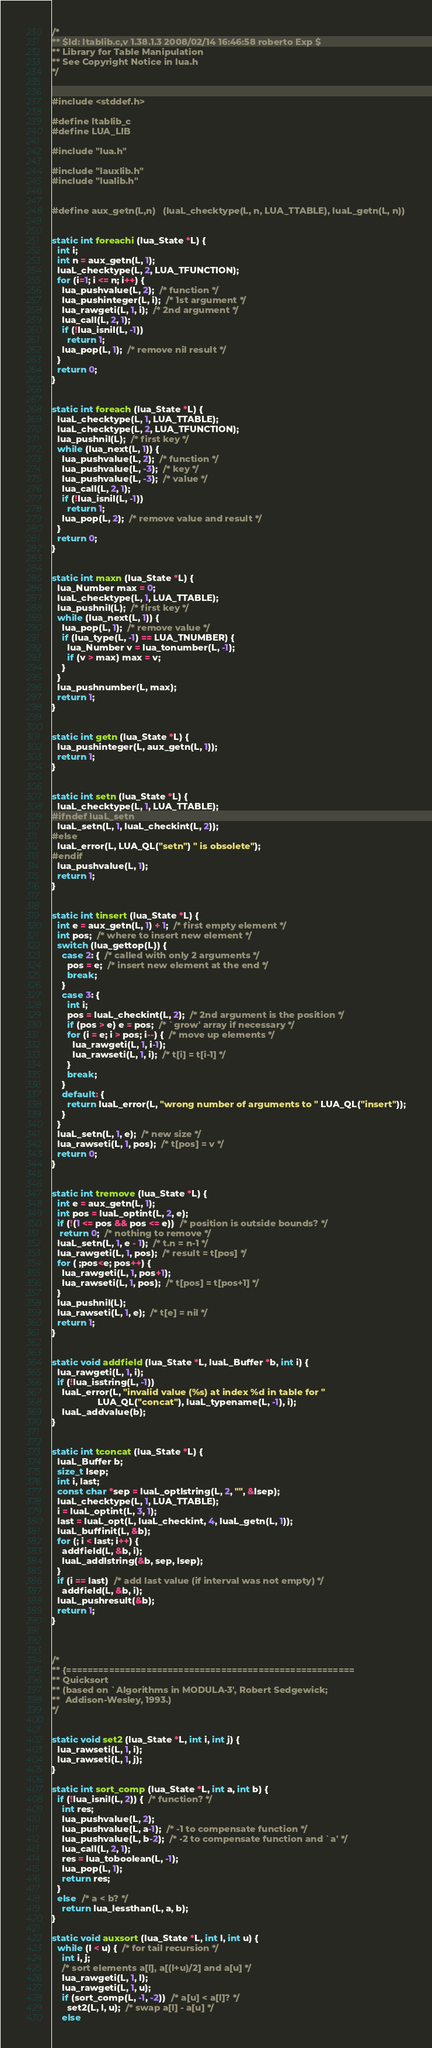<code> <loc_0><loc_0><loc_500><loc_500><_C_>/*
** $Id: ltablib.c,v 1.38.1.3 2008/02/14 16:46:58 roberto Exp $
** Library for Table Manipulation
** See Copyright Notice in lua.h
*/


#include <stddef.h>

#define ltablib_c
#define LUA_LIB

#include "lua.h"

#include "lauxlib.h"
#include "lualib.h"


#define aux_getn(L,n)   (luaL_checktype(L, n, LUA_TTABLE), luaL_getn(L, n))


static int foreachi (lua_State *L) {
  int i;
  int n = aux_getn(L, 1);
  luaL_checktype(L, 2, LUA_TFUNCTION);
  for (i=1; i <= n; i++) {
    lua_pushvalue(L, 2);  /* function */
    lua_pushinteger(L, i);  /* 1st argument */
    lua_rawgeti(L, 1, i);  /* 2nd argument */
    lua_call(L, 2, 1);
    if (!lua_isnil(L, -1))
      return 1;
    lua_pop(L, 1);  /* remove nil result */
  }
  return 0;
}


static int foreach (lua_State *L) {
  luaL_checktype(L, 1, LUA_TTABLE);
  luaL_checktype(L, 2, LUA_TFUNCTION);
  lua_pushnil(L);  /* first key */
  while (lua_next(L, 1)) {
    lua_pushvalue(L, 2);  /* function */
    lua_pushvalue(L, -3);  /* key */
    lua_pushvalue(L, -3);  /* value */
    lua_call(L, 2, 1);
    if (!lua_isnil(L, -1))
      return 1;
    lua_pop(L, 2);  /* remove value and result */
  }
  return 0;
}


static int maxn (lua_State *L) {
  lua_Number max = 0;
  luaL_checktype(L, 1, LUA_TTABLE);
  lua_pushnil(L);  /* first key */
  while (lua_next(L, 1)) {
    lua_pop(L, 1);  /* remove value */
    if (lua_type(L, -1) == LUA_TNUMBER) {
      lua_Number v = lua_tonumber(L, -1);
      if (v > max) max = v;
    }
  }
  lua_pushnumber(L, max);
  return 1;
}


static int getn (lua_State *L) {
  lua_pushinteger(L, aux_getn(L, 1));
  return 1;
}


static int setn (lua_State *L) {
  luaL_checktype(L, 1, LUA_TTABLE);
#ifndef luaL_setn
  luaL_setn(L, 1, luaL_checkint(L, 2));
#else
  luaL_error(L, LUA_QL("setn") " is obsolete");
#endif
  lua_pushvalue(L, 1);
  return 1;
}


static int tinsert (lua_State *L) {
  int e = aux_getn(L, 1) + 1;  /* first empty element */
  int pos;  /* where to insert new element */
  switch (lua_gettop(L)) {
    case 2: {  /* called with only 2 arguments */
      pos = e;  /* insert new element at the end */
      break;
    }
    case 3: {
      int i;
      pos = luaL_checkint(L, 2);  /* 2nd argument is the position */
      if (pos > e) e = pos;  /* `grow' array if necessary */
      for (i = e; i > pos; i--) {  /* move up elements */
        lua_rawgeti(L, 1, i-1);
        lua_rawseti(L, 1, i);  /* t[i] = t[i-1] */
      }
      break;
    }
    default: {
      return luaL_error(L, "wrong number of arguments to " LUA_QL("insert"));
    }
  }
  luaL_setn(L, 1, e);  /* new size */
  lua_rawseti(L, 1, pos);  /* t[pos] = v */
  return 0;
}


static int tremove (lua_State *L) {
  int e = aux_getn(L, 1);
  int pos = luaL_optint(L, 2, e);
  if (!(1 <= pos && pos <= e))  /* position is outside bounds? */
   return 0;  /* nothing to remove */
  luaL_setn(L, 1, e - 1);  /* t.n = n-1 */
  lua_rawgeti(L, 1, pos);  /* result = t[pos] */
  for ( ;pos<e; pos++) {
    lua_rawgeti(L, 1, pos+1);
    lua_rawseti(L, 1, pos);  /* t[pos] = t[pos+1] */
  }
  lua_pushnil(L);
  lua_rawseti(L, 1, e);  /* t[e] = nil */
  return 1;
}


static void addfield (lua_State *L, luaL_Buffer *b, int i) {
  lua_rawgeti(L, 1, i);
  if (!lua_isstring(L, -1))
    luaL_error(L, "invalid value (%s) at index %d in table for "
                  LUA_QL("concat"), luaL_typename(L, -1), i);
    luaL_addvalue(b);
}


static int tconcat (lua_State *L) {
  luaL_Buffer b;
  size_t lsep;
  int i, last;
  const char *sep = luaL_optlstring(L, 2, "", &lsep);
  luaL_checktype(L, 1, LUA_TTABLE);
  i = luaL_optint(L, 3, 1);
  last = luaL_opt(L, luaL_checkint, 4, luaL_getn(L, 1));
  luaL_buffinit(L, &b);
  for (; i < last; i++) {
    addfield(L, &b, i);
    luaL_addlstring(&b, sep, lsep);
  }
  if (i == last)  /* add last value (if interval was not empty) */
    addfield(L, &b, i);
  luaL_pushresult(&b);
  return 1;
}



/*
** {======================================================
** Quicksort
** (based on `Algorithms in MODULA-3', Robert Sedgewick;
**  Addison-Wesley, 1993.)
*/


static void set2 (lua_State *L, int i, int j) {
  lua_rawseti(L, 1, i);
  lua_rawseti(L, 1, j);
}

static int sort_comp (lua_State *L, int a, int b) {
  if (!lua_isnil(L, 2)) {  /* function? */
    int res;
    lua_pushvalue(L, 2);
    lua_pushvalue(L, a-1);  /* -1 to compensate function */
    lua_pushvalue(L, b-2);  /* -2 to compensate function and `a' */
    lua_call(L, 2, 1);
    res = lua_toboolean(L, -1);
    lua_pop(L, 1);
    return res;
  }
  else  /* a < b? */
    return lua_lessthan(L, a, b);
}

static void auxsort (lua_State *L, int l, int u) {
  while (l < u) {  /* for tail recursion */
    int i, j;
    /* sort elements a[l], a[(l+u)/2] and a[u] */
    lua_rawgeti(L, 1, l);
    lua_rawgeti(L, 1, u);
    if (sort_comp(L, -1, -2))  /* a[u] < a[l]? */
      set2(L, l, u);  /* swap a[l] - a[u] */
    else</code> 